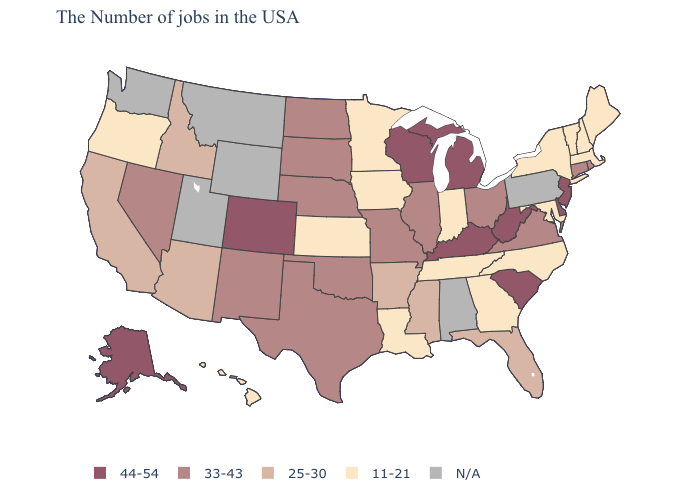What is the value of New York?
Answer briefly. 11-21. What is the value of Virginia?
Quick response, please. 33-43. Among the states that border Montana , does South Dakota have the highest value?
Quick response, please. Yes. Among the states that border Idaho , which have the lowest value?
Answer briefly. Oregon. Does Indiana have the lowest value in the MidWest?
Short answer required. Yes. What is the value of North Carolina?
Be succinct. 11-21. What is the highest value in states that border Montana?
Give a very brief answer. 33-43. Which states hav the highest value in the MidWest?
Give a very brief answer. Michigan, Wisconsin. Name the states that have a value in the range N/A?
Quick response, please. Pennsylvania, Alabama, Wyoming, Utah, Montana, Washington. What is the lowest value in the South?
Write a very short answer. 11-21. Name the states that have a value in the range 25-30?
Keep it brief. Florida, Mississippi, Arkansas, Arizona, Idaho, California. What is the highest value in states that border New Mexico?
Quick response, please. 44-54. 